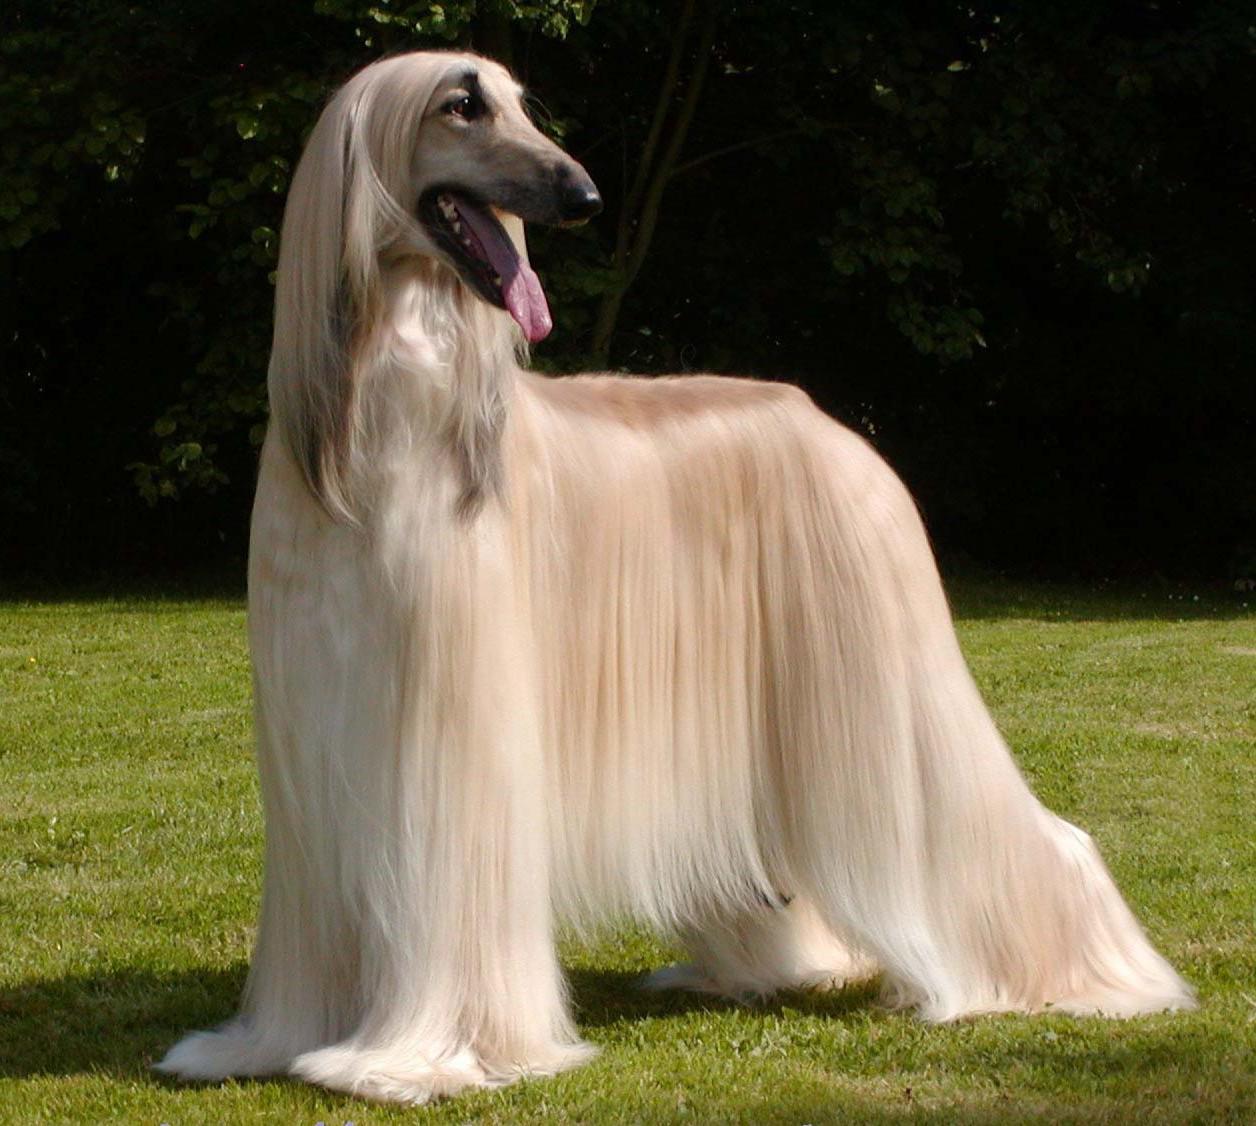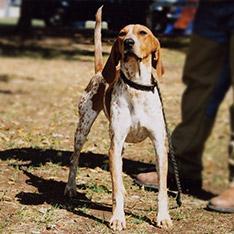The first image is the image on the left, the second image is the image on the right. Examine the images to the left and right. Is the description "The dog in the image on the right is turned toward and facing the camera." accurate? Answer yes or no. Yes. 